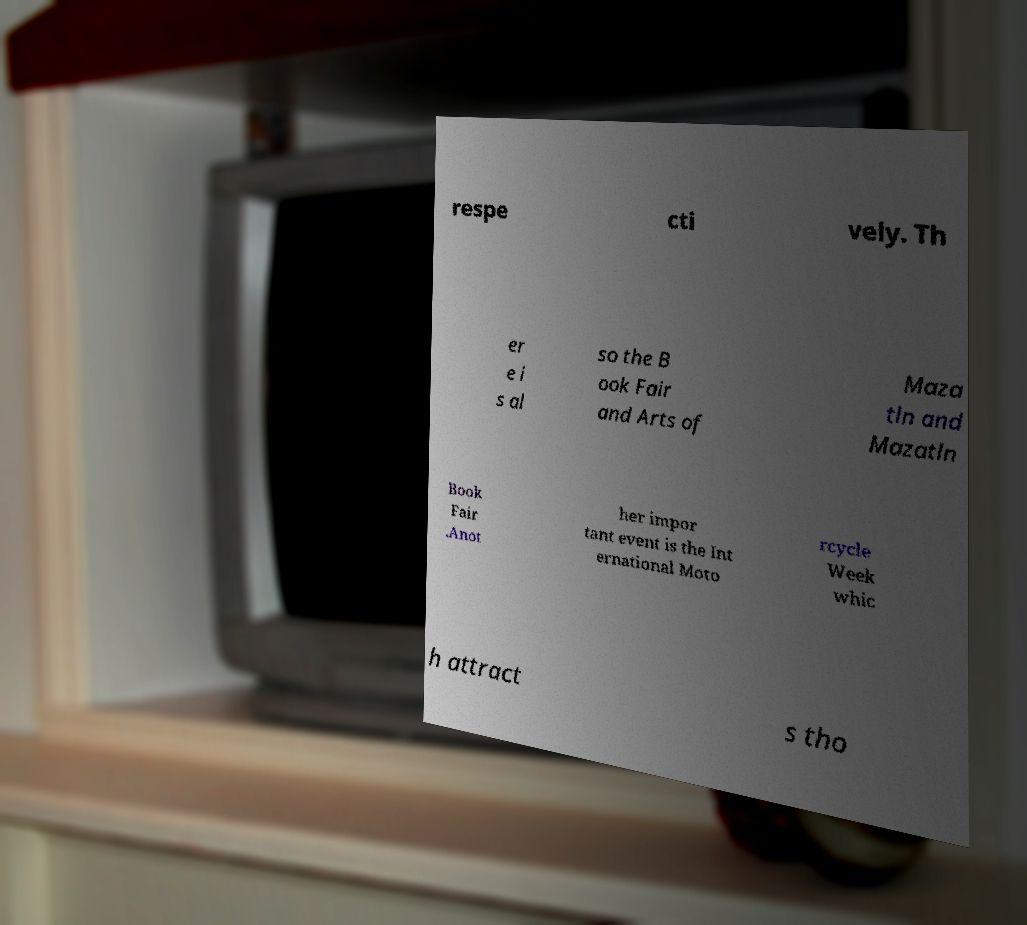There's text embedded in this image that I need extracted. Can you transcribe it verbatim? respe cti vely. Th er e i s al so the B ook Fair and Arts of Maza tln and Mazatln Book Fair .Anot her impor tant event is the Int ernational Moto rcycle Week whic h attract s tho 